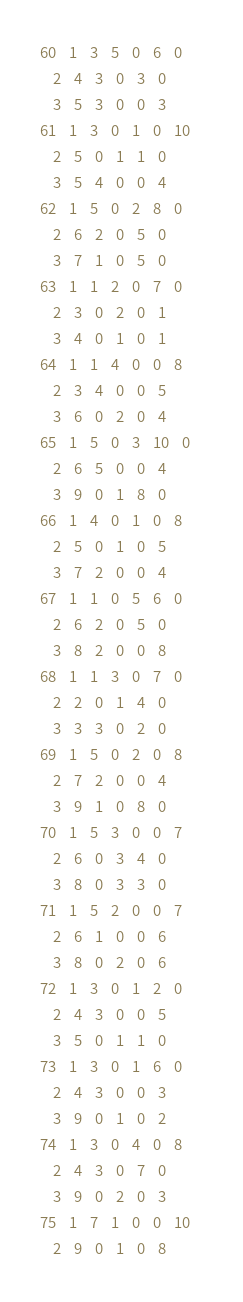<code> <loc_0><loc_0><loc_500><loc_500><_ObjectiveC_>60	1	3	5	0	6	0	
	2	4	3	0	3	0	
	3	5	3	0	0	3	
61	1	3	0	1	0	10	
	2	5	0	1	1	0	
	3	5	4	0	0	4	
62	1	5	0	2	8	0	
	2	6	2	0	5	0	
	3	7	1	0	5	0	
63	1	1	2	0	7	0	
	2	3	0	2	0	1	
	3	4	0	1	0	1	
64	1	1	4	0	0	8	
	2	3	4	0	0	5	
	3	6	0	2	0	4	
65	1	5	0	3	10	0	
	2	6	5	0	0	4	
	3	9	0	1	8	0	
66	1	4	0	1	0	8	
	2	5	0	1	0	5	
	3	7	2	0	0	4	
67	1	1	0	5	6	0	
	2	6	2	0	5	0	
	3	8	2	0	0	8	
68	1	1	3	0	7	0	
	2	2	0	1	4	0	
	3	3	3	0	2	0	
69	1	5	0	2	0	8	
	2	7	2	0	0	4	
	3	9	1	0	8	0	
70	1	5	3	0	0	7	
	2	6	0	3	4	0	
	3	8	0	3	3	0	
71	1	5	2	0	0	7	
	2	6	1	0	0	6	
	3	8	0	2	0	6	
72	1	3	0	1	2	0	
	2	4	3	0	0	5	
	3	5	0	1	1	0	
73	1	3	0	1	6	0	
	2	4	3	0	0	3	
	3	9	0	1	0	2	
74	1	3	0	4	0	8	
	2	4	3	0	7	0	
	3	9	0	2	0	3	
75	1	7	1	0	0	10	
	2	9	0	1	0	8	</code> 